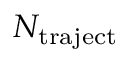<formula> <loc_0><loc_0><loc_500><loc_500>N _ { t r a j e c t }</formula> 